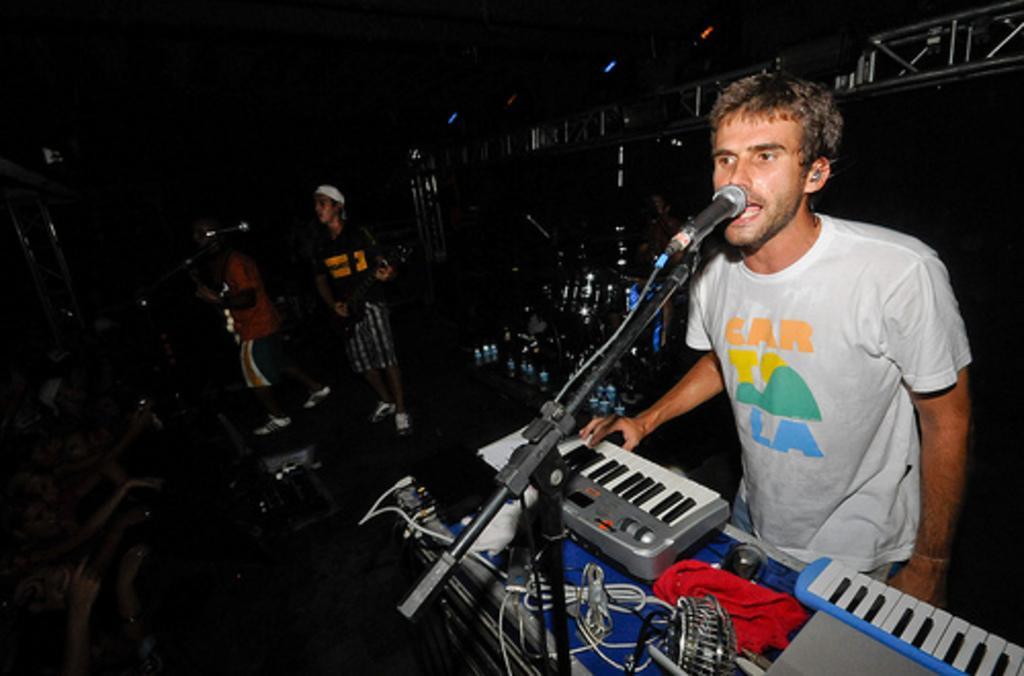Could you give a brief overview of what you see in this image? In this image in front there is a person playing a musical instrument. Beside him there are two people playing a guitar. In front of them there are mikes and other musical instruments. On the left side of the image there are few people. In the background of the image there is a metal fence. 